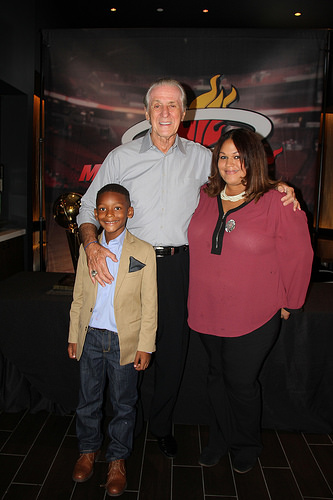<image>
Can you confirm if the handkerchief is on the man? No. The handkerchief is not positioned on the man. They may be near each other, but the handkerchief is not supported by or resting on top of the man. Where is the man in relation to the boy? Is it behind the boy? Yes. From this viewpoint, the man is positioned behind the boy, with the boy partially or fully occluding the man. 